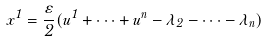<formula> <loc_0><loc_0><loc_500><loc_500>x ^ { 1 } = \frac { \varepsilon } { 2 } ( u ^ { 1 } + \cdots + u ^ { n } - \lambda _ { 2 } - \cdots - \lambda _ { n } )</formula> 